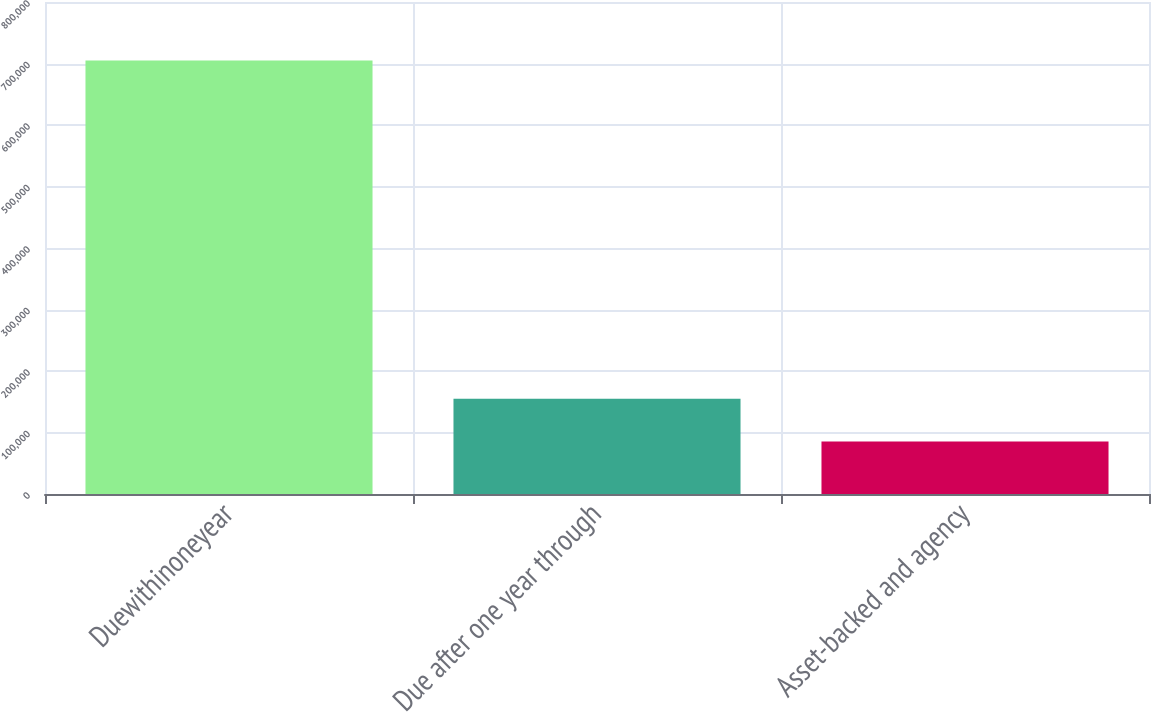Convert chart to OTSL. <chart><loc_0><loc_0><loc_500><loc_500><bar_chart><fcel>Duewithinoneyear<fcel>Due after one year through<fcel>Asset-backed and agency<nl><fcel>704982<fcel>155048<fcel>85403<nl></chart> 